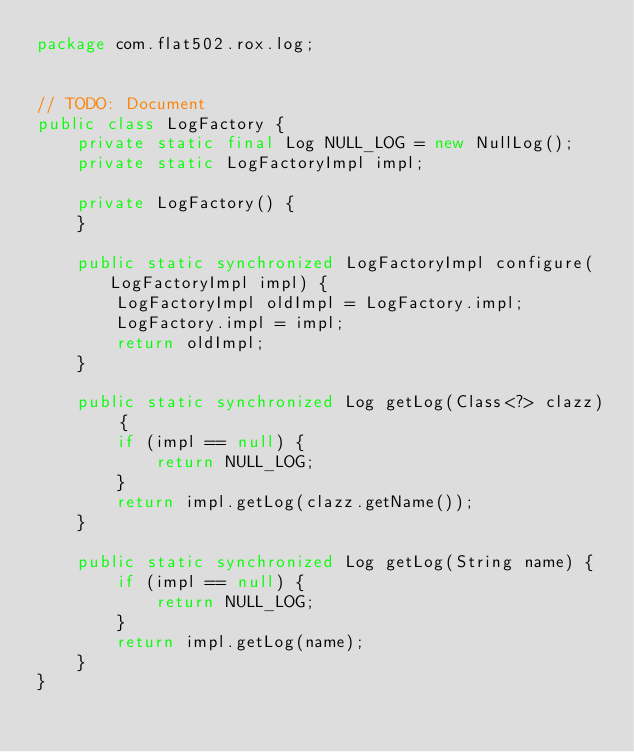<code> <loc_0><loc_0><loc_500><loc_500><_Java_>package com.flat502.rox.log;


// TODO: Document
public class LogFactory {
	private static final Log NULL_LOG = new NullLog();
	private static LogFactoryImpl impl;
	
	private LogFactory() {
	}
	
	public static synchronized LogFactoryImpl configure(LogFactoryImpl impl) {
		LogFactoryImpl oldImpl = LogFactory.impl;
		LogFactory.impl = impl;
		return oldImpl;
	}
	
	public static synchronized Log getLog(Class<?> clazz) {
		if (impl == null) {
			return NULL_LOG;
		}
		return impl.getLog(clazz.getName());
	}

	public static synchronized Log getLog(String name) {
		if (impl == null) {
			return NULL_LOG;
		}
		return impl.getLog(name);
	}
}
</code> 